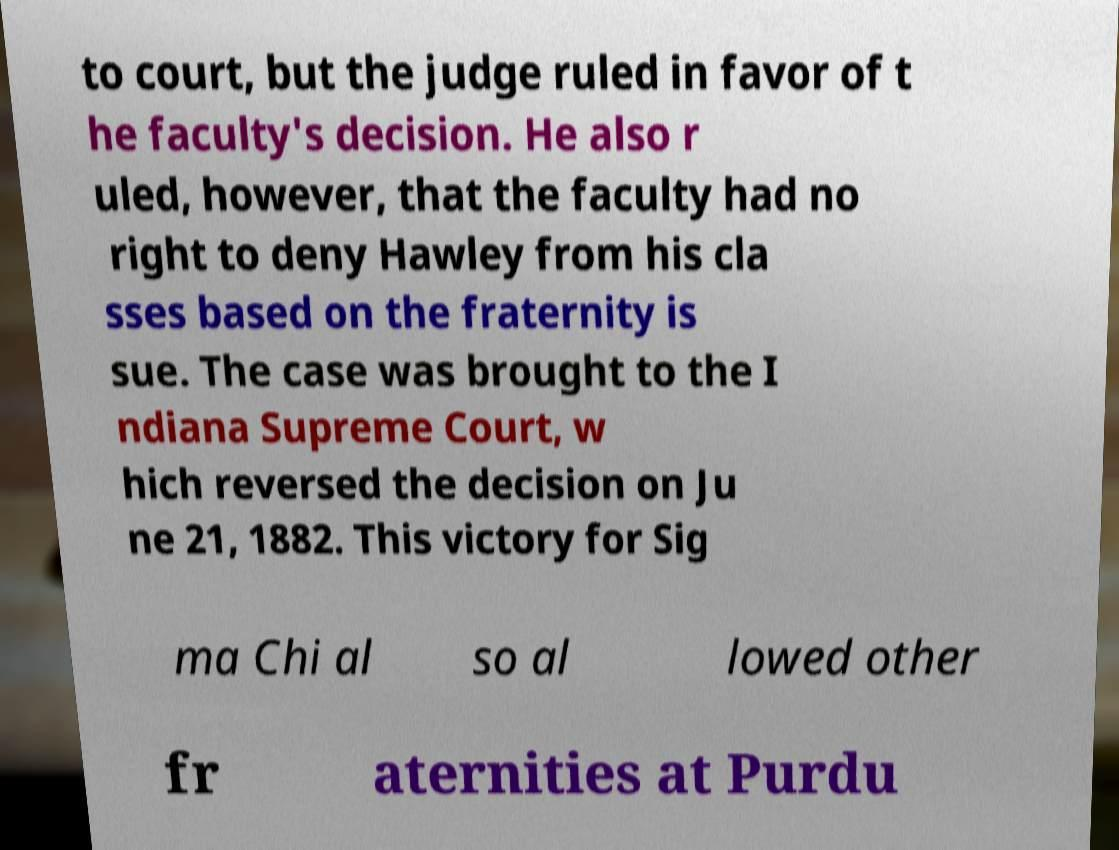What messages or text are displayed in this image? I need them in a readable, typed format. to court, but the judge ruled in favor of t he faculty's decision. He also r uled, however, that the faculty had no right to deny Hawley from his cla sses based on the fraternity is sue. The case was brought to the I ndiana Supreme Court, w hich reversed the decision on Ju ne 21, 1882. This victory for Sig ma Chi al so al lowed other fr aternities at Purdu 